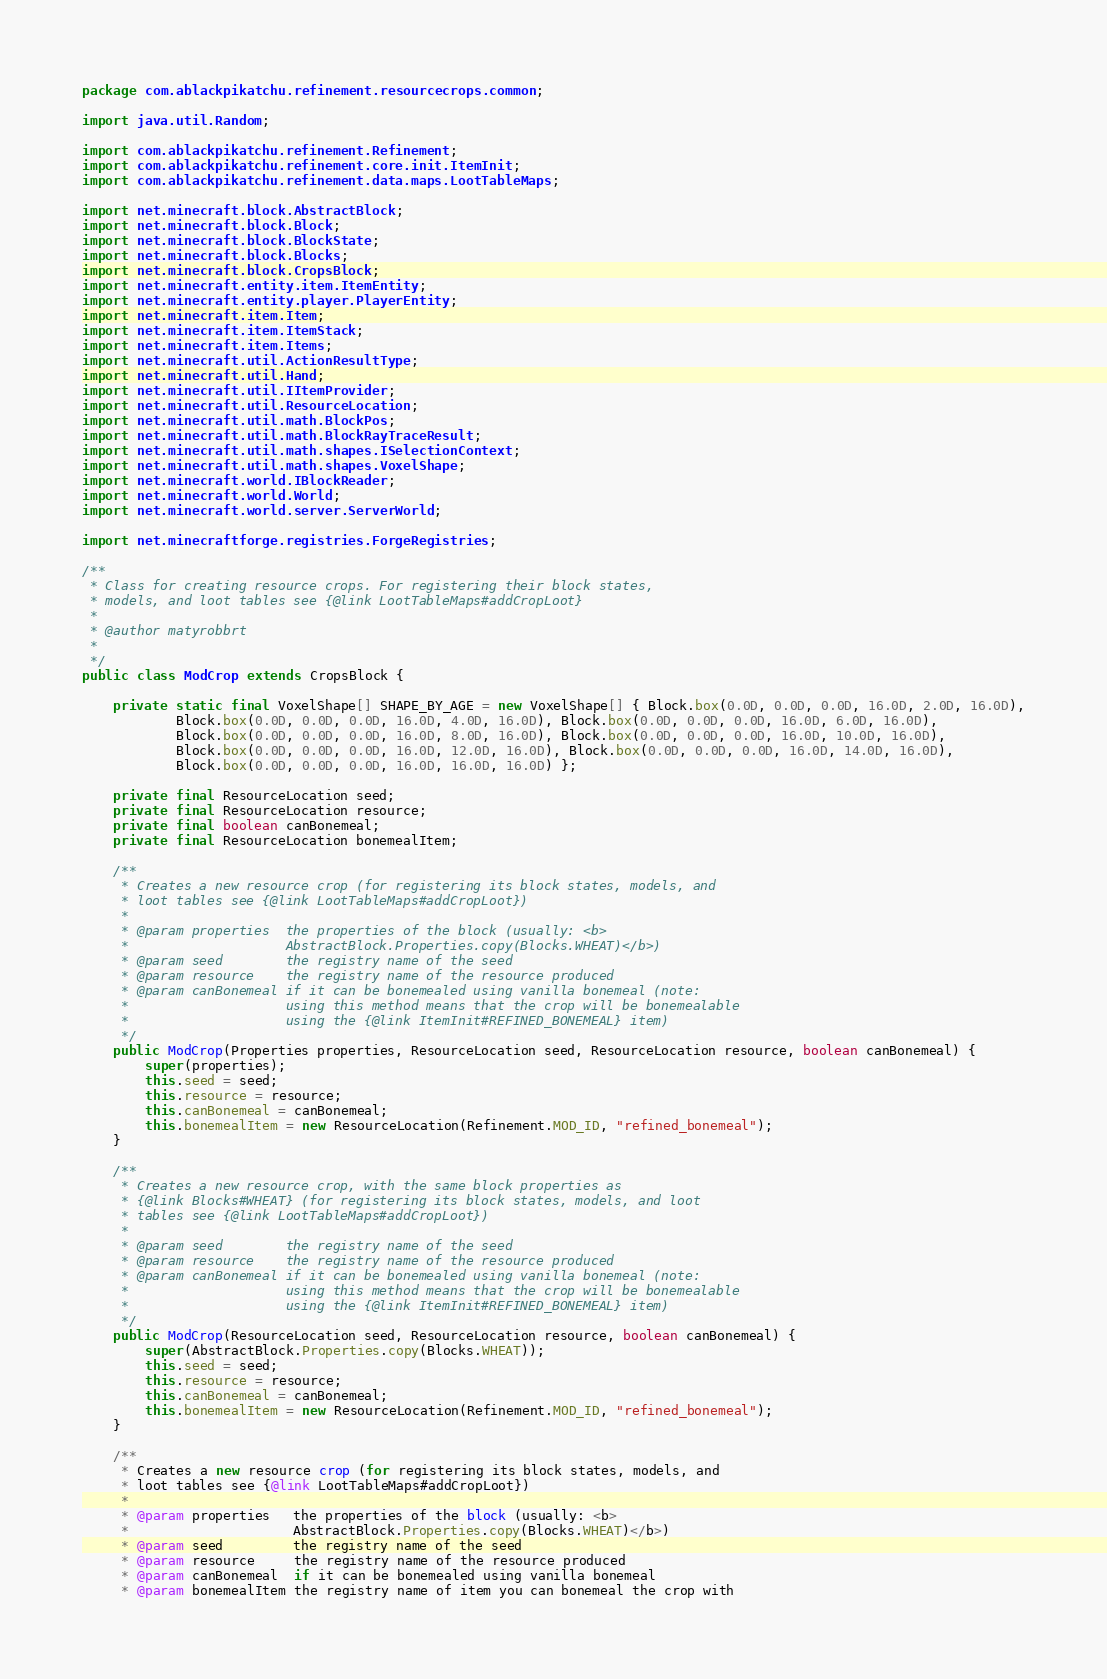<code> <loc_0><loc_0><loc_500><loc_500><_Java_>package com.ablackpikatchu.refinement.resourcecrops.common;

import java.util.Random;

import com.ablackpikatchu.refinement.Refinement;
import com.ablackpikatchu.refinement.core.init.ItemInit;
import com.ablackpikatchu.refinement.data.maps.LootTableMaps;

import net.minecraft.block.AbstractBlock;
import net.minecraft.block.Block;
import net.minecraft.block.BlockState;
import net.minecraft.block.Blocks;
import net.minecraft.block.CropsBlock;
import net.minecraft.entity.item.ItemEntity;
import net.minecraft.entity.player.PlayerEntity;
import net.minecraft.item.Item;
import net.minecraft.item.ItemStack;
import net.minecraft.item.Items;
import net.minecraft.util.ActionResultType;
import net.minecraft.util.Hand;
import net.minecraft.util.IItemProvider;
import net.minecraft.util.ResourceLocation;
import net.minecraft.util.math.BlockPos;
import net.minecraft.util.math.BlockRayTraceResult;
import net.minecraft.util.math.shapes.ISelectionContext;
import net.minecraft.util.math.shapes.VoxelShape;
import net.minecraft.world.IBlockReader;
import net.minecraft.world.World;
import net.minecraft.world.server.ServerWorld;

import net.minecraftforge.registries.ForgeRegistries;

/**
 * Class for creating resource crops. For registering their block states,
 * models, and loot tables see {@link LootTableMaps#addCropLoot}
 * 
 * @author matyrobbrt
 *
 */
public class ModCrop extends CropsBlock {

	private static final VoxelShape[] SHAPE_BY_AGE = new VoxelShape[] { Block.box(0.0D, 0.0D, 0.0D, 16.0D, 2.0D, 16.0D),
			Block.box(0.0D, 0.0D, 0.0D, 16.0D, 4.0D, 16.0D), Block.box(0.0D, 0.0D, 0.0D, 16.0D, 6.0D, 16.0D),
			Block.box(0.0D, 0.0D, 0.0D, 16.0D, 8.0D, 16.0D), Block.box(0.0D, 0.0D, 0.0D, 16.0D, 10.0D, 16.0D),
			Block.box(0.0D, 0.0D, 0.0D, 16.0D, 12.0D, 16.0D), Block.box(0.0D, 0.0D, 0.0D, 16.0D, 14.0D, 16.0D),
			Block.box(0.0D, 0.0D, 0.0D, 16.0D, 16.0D, 16.0D) };

	private final ResourceLocation seed;
	private final ResourceLocation resource;
	private final boolean canBonemeal;
	private final ResourceLocation bonemealItem;

	/**
	 * Creates a new resource crop (for registering its block states, models, and
	 * loot tables see {@link LootTableMaps#addCropLoot})
	 * 
	 * @param properties  the properties of the block (usually: <b>
	 *                    AbstractBlock.Properties.copy(Blocks.WHEAT)</b>)
	 * @param seed        the registry name of the seed
	 * @param resource    the registry name of the resource produced
	 * @param canBonemeal if it can be bonemealed using vanilla bonemeal (note:
	 *                    using this method means that the crop will be bonemealable
	 *                    using the {@link ItemInit#REFINED_BONEMEAL} item)
	 */
	public ModCrop(Properties properties, ResourceLocation seed, ResourceLocation resource, boolean canBonemeal) {
		super(properties);
		this.seed = seed;
		this.resource = resource;
		this.canBonemeal = canBonemeal;
		this.bonemealItem = new ResourceLocation(Refinement.MOD_ID, "refined_bonemeal");
	}

	/**
	 * Creates a new resource crop, with the same block properties as
	 * {@link Blocks#WHEAT} (for registering its block states, models, and loot
	 * tables see {@link LootTableMaps#addCropLoot})
	 * 
	 * @param seed        the registry name of the seed
	 * @param resource    the registry name of the resource produced
	 * @param canBonemeal if it can be bonemealed using vanilla bonemeal (note:
	 *                    using this method means that the crop will be bonemealable
	 *                    using the {@link ItemInit#REFINED_BONEMEAL} item)
	 */
	public ModCrop(ResourceLocation seed, ResourceLocation resource, boolean canBonemeal) {
		super(AbstractBlock.Properties.copy(Blocks.WHEAT));
		this.seed = seed;
		this.resource = resource;
		this.canBonemeal = canBonemeal;
		this.bonemealItem = new ResourceLocation(Refinement.MOD_ID, "refined_bonemeal");
	}

	/**
	 * Creates a new resource crop (for registering its block states, models, and
	 * loot tables see {@link LootTableMaps#addCropLoot})
	 * 
	 * @param properties   the properties of the block (usually: <b>
	 *                     AbstractBlock.Properties.copy(Blocks.WHEAT)</b>)
	 * @param seed         the registry name of the seed
	 * @param resource     the registry name of the resource produced
	 * @param canBonemeal  if it can be bonemealed using vanilla bonemeal
	 * @param bonemealItem the registry name of item you can bonemeal the crop with</code> 